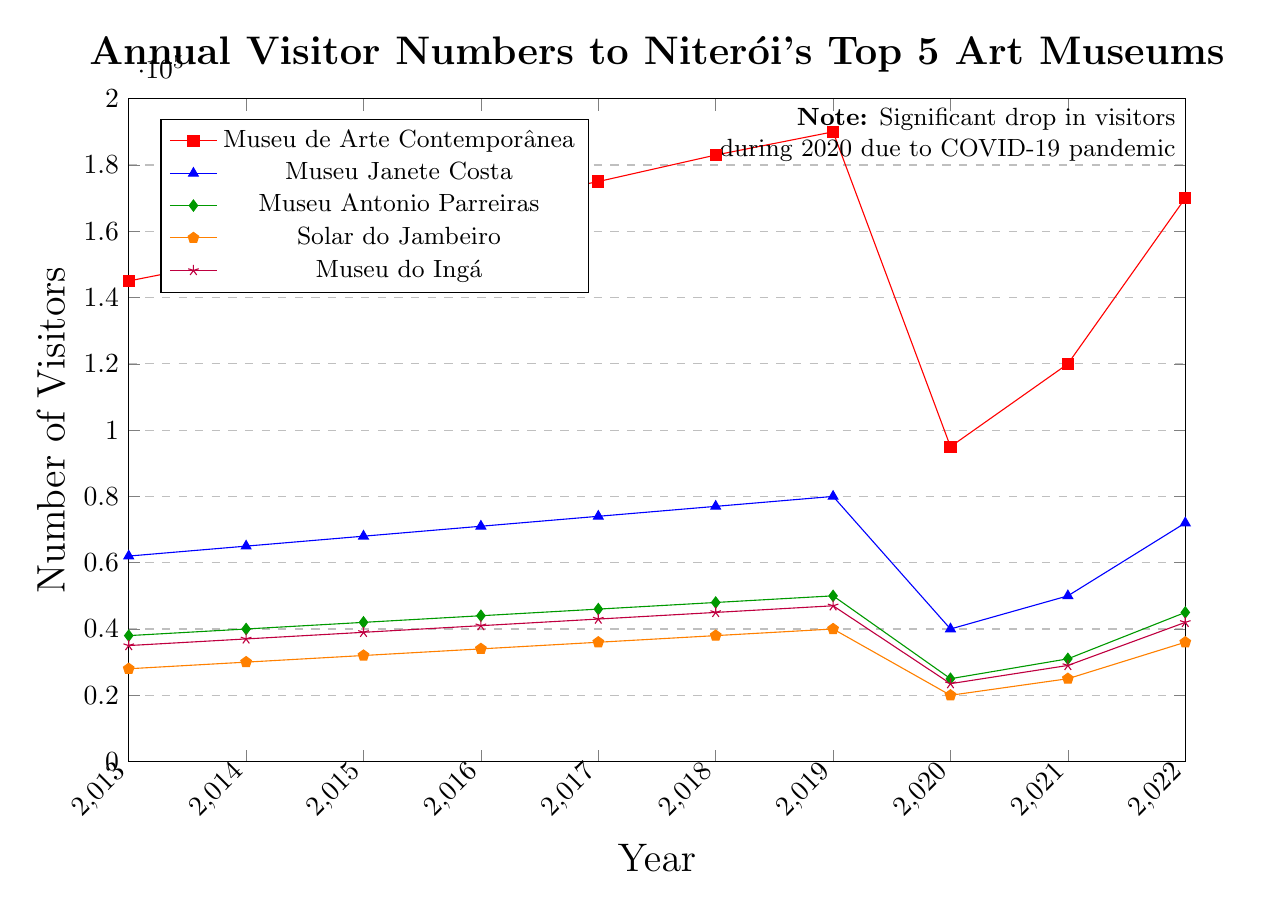What was the number of visitors to the Museu de Arte Contemporânea in the year 2018? The figure indicates that the Museu de Arte Contemporânea had 183,000 visitors in the year 2018.
Answer: 183,000 Which museum had the highest number of visitors in the year 2016? In 2016, the figure shows that the Museu de Arte Contemporânea had the highest number of visitors among the listed museums with 168,000.
Answer: Museu de Arte Contemporânea How did the visitor numbers for the Museu Janete Costa change from 2019 to 2020 and from 2020 to 2021? From 2019 to 2020, visitor numbers for the Museu Janete Costa decreased from 80,000 to 40,000. From 2020 to 2021, visitor numbers increased from 40,000 to 50,000.
Answer: Decreased by 40,000; Increased by 10,000 Was there a museum whose visitor count did not decrease in 2020? All the museums listed in the figure show a significant drop in visitor numbers for the year 2020, primarily due to the COVID-19 pandemic.
Answer: No Which museum saw the highest increase in visitor numbers from 2021 to 2022? By comparing the visitor numbers from 2021 to 2022, the Museu de Arte Contemporânea exhibits the largest increase, from 120,000 to 170,000, an increase of 50,000 visitors.
Answer: Museu de Arte Contemporânea What was the average number of visitors to the Museu Antonio Parreiras between the years 2013 to 2019? The visitor numbers for Museu Antonio Parreiras from 2013 to 2019 are: 38,000, 40,000, 42,000, 44,000, 46,000, 48,000, and 50,000. Adding these numbers gives a total of 308,000. Dividing by 7 years gives an average of 44,000 visitors per year.
Answer: 44,000 Which museum had fewer visitors in 2021 compared to its 2013 numbers? Comparing the visitor numbers for 2013 and 2021, the Museu Antonio Parreiras had a decrease from 38,000 visitors in 2013 to 31,000 in 2021.
Answer: Museu Antonio Parreiras By how much did the number of visitors to Solar do Jambeiro change from 2019 to 2022? The number of visitors to Solar do Jambeiro changed from 40,000 in 2019 to 36,000 in 2022, a decrease of 4,000 visitors.
Answer: Decreased by 4,000 Which museum had the most stable visitor numbers over the decade, and how can you tell? Museu Antonio Parreiras had the most stable visitor numbers over the decade as there were no dramatic increases or decreases, showing a gradual and consistent rise and fall.
Answer: Museu Antonio Parreiras 